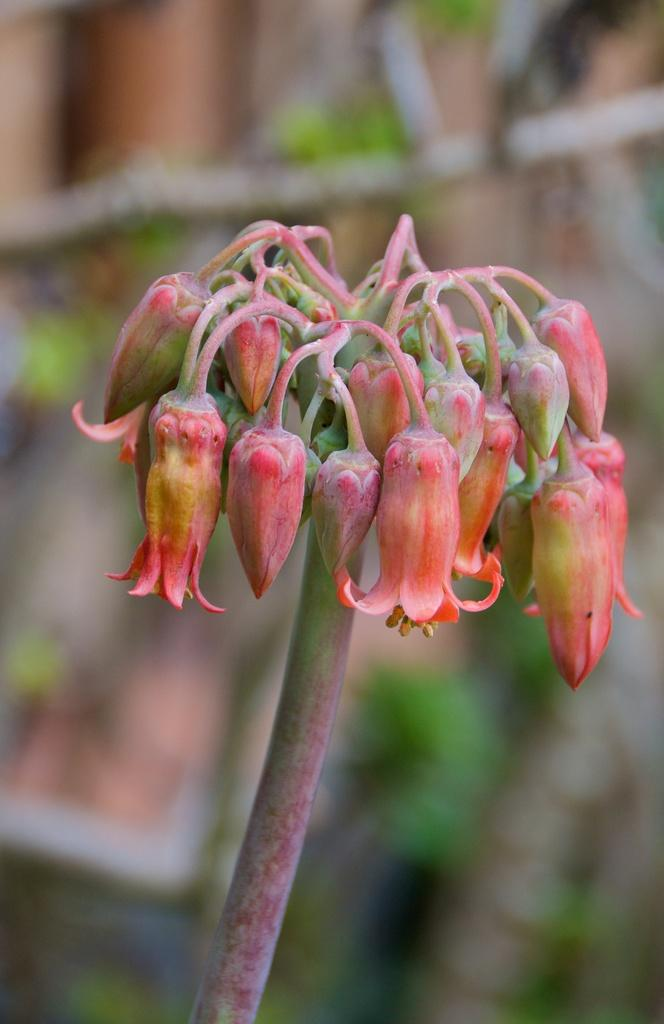What is located in the foreground of the image? There is a plant in the foreground of the image. How many babies are playing with the mice in the image? There are no babies or mice present in the image; it features a plant in the foreground. 